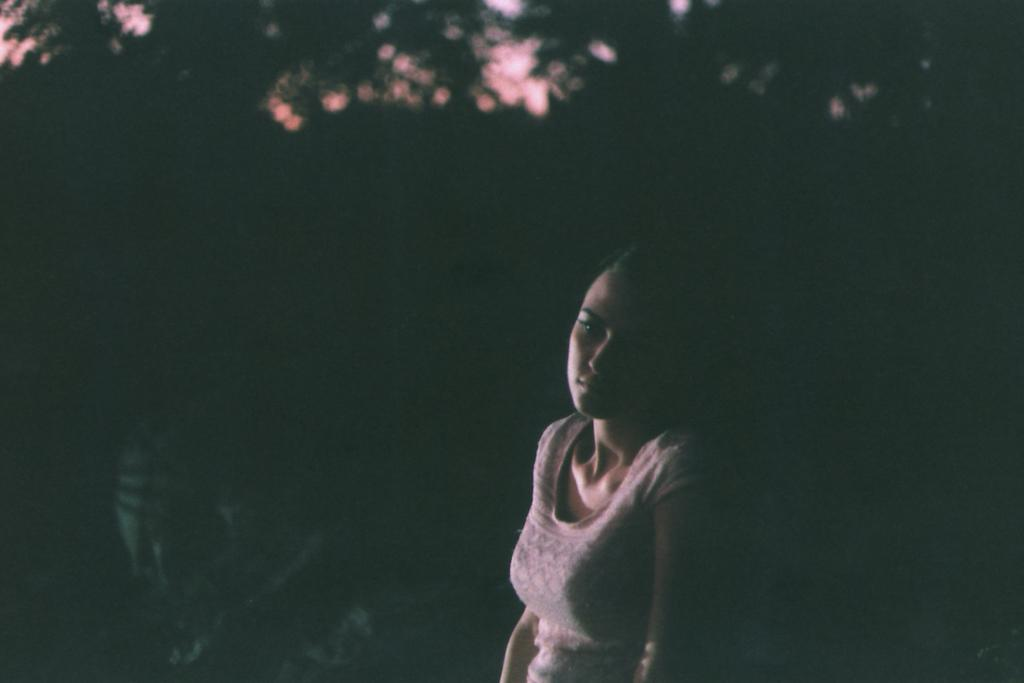Who is present in the image? There is a woman in the image. What is the woman wearing? The woman is wearing a white t-shirt. What can be seen in the background of the image? There are trees and the sky visible in the background of the image. What type of yarn is the woman using to knit in the image? There is no yarn or knitting activity present in the image. What does the woman believe about the existence of aliens? The image does not provide any information about the woman's beliefs or opinions, including her beliefs about aliens. 